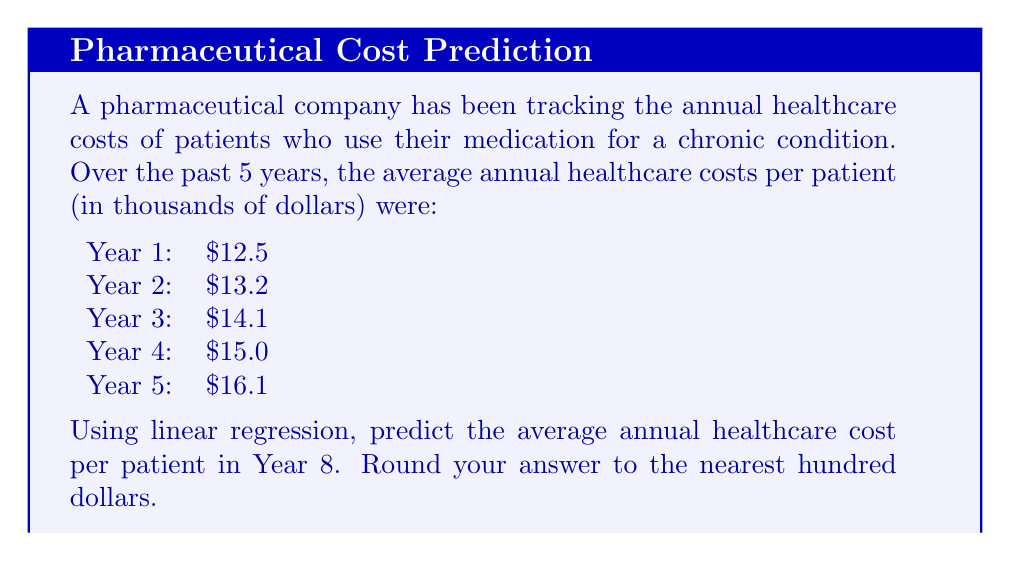Provide a solution to this math problem. To predict future healthcare costs using linear regression, we'll follow these steps:

1. Assign x-values to each year (1-5) and use the given costs as y-values.

2. Calculate the means of x and y:
   $\bar{x} = \frac{1+2+3+4+5}{5} = 3$
   $\bar{y} = \frac{12.5+13.2+14.1+15.0+16.1}{5} = 14.18$

3. Calculate the slope (m) using the formula:
   $$m = \frac{\sum(x-\bar{x})(y-\bar{y})}{\sum(x-\bar{x})^2}$$

   $(x-\bar{x})(y-\bar{y})$ values: $-6.84, -2.94, 0.06, 3.16, 6.56$
   Sum: $0$

   $(x-\bar{x})^2$ values: $4, 1, 0, 1, 4$
   Sum: $10$

   $m = \frac{0}{10} = 0.9$

4. Calculate the y-intercept (b) using $y = mx + b$:
   $14.18 = 0.9(3) + b$
   $b = 14.18 - 2.7 = 11.48$

5. The linear regression equation is:
   $y = 0.9x + 11.48$

6. To predict Year 8, substitute x = 8:
   $y = 0.9(8) + 11.48 = 18.68$

Therefore, the predicted average annual healthcare cost per patient in Year 8 is $18,680.
Answer: $18,700 